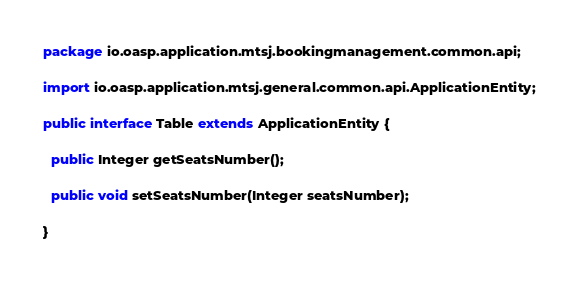<code> <loc_0><loc_0><loc_500><loc_500><_Java_>package io.oasp.application.mtsj.bookingmanagement.common.api;

import io.oasp.application.mtsj.general.common.api.ApplicationEntity;

public interface Table extends ApplicationEntity {

  public Integer getSeatsNumber();

  public void setSeatsNumber(Integer seatsNumber);

}
</code> 